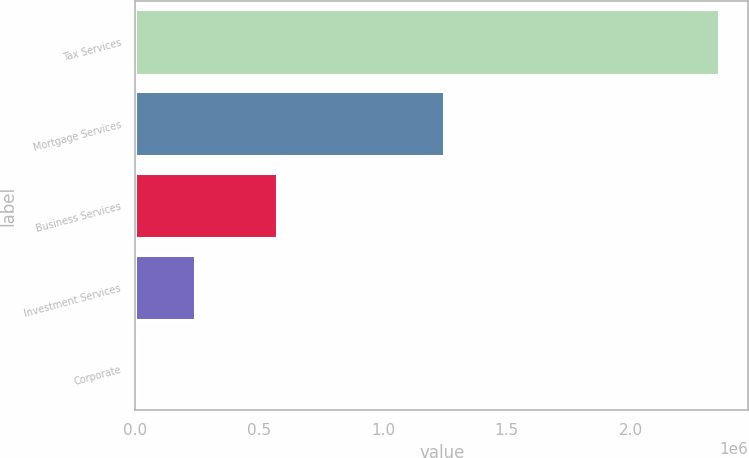Convert chart. <chart><loc_0><loc_0><loc_500><loc_500><bar_chart><fcel>Tax Services<fcel>Mortgage Services<fcel>Business Services<fcel>Investment Services<fcel>Corporate<nl><fcel>2.35829e+06<fcel>1.24602e+06<fcel>573316<fcel>239244<fcel>3148<nl></chart> 